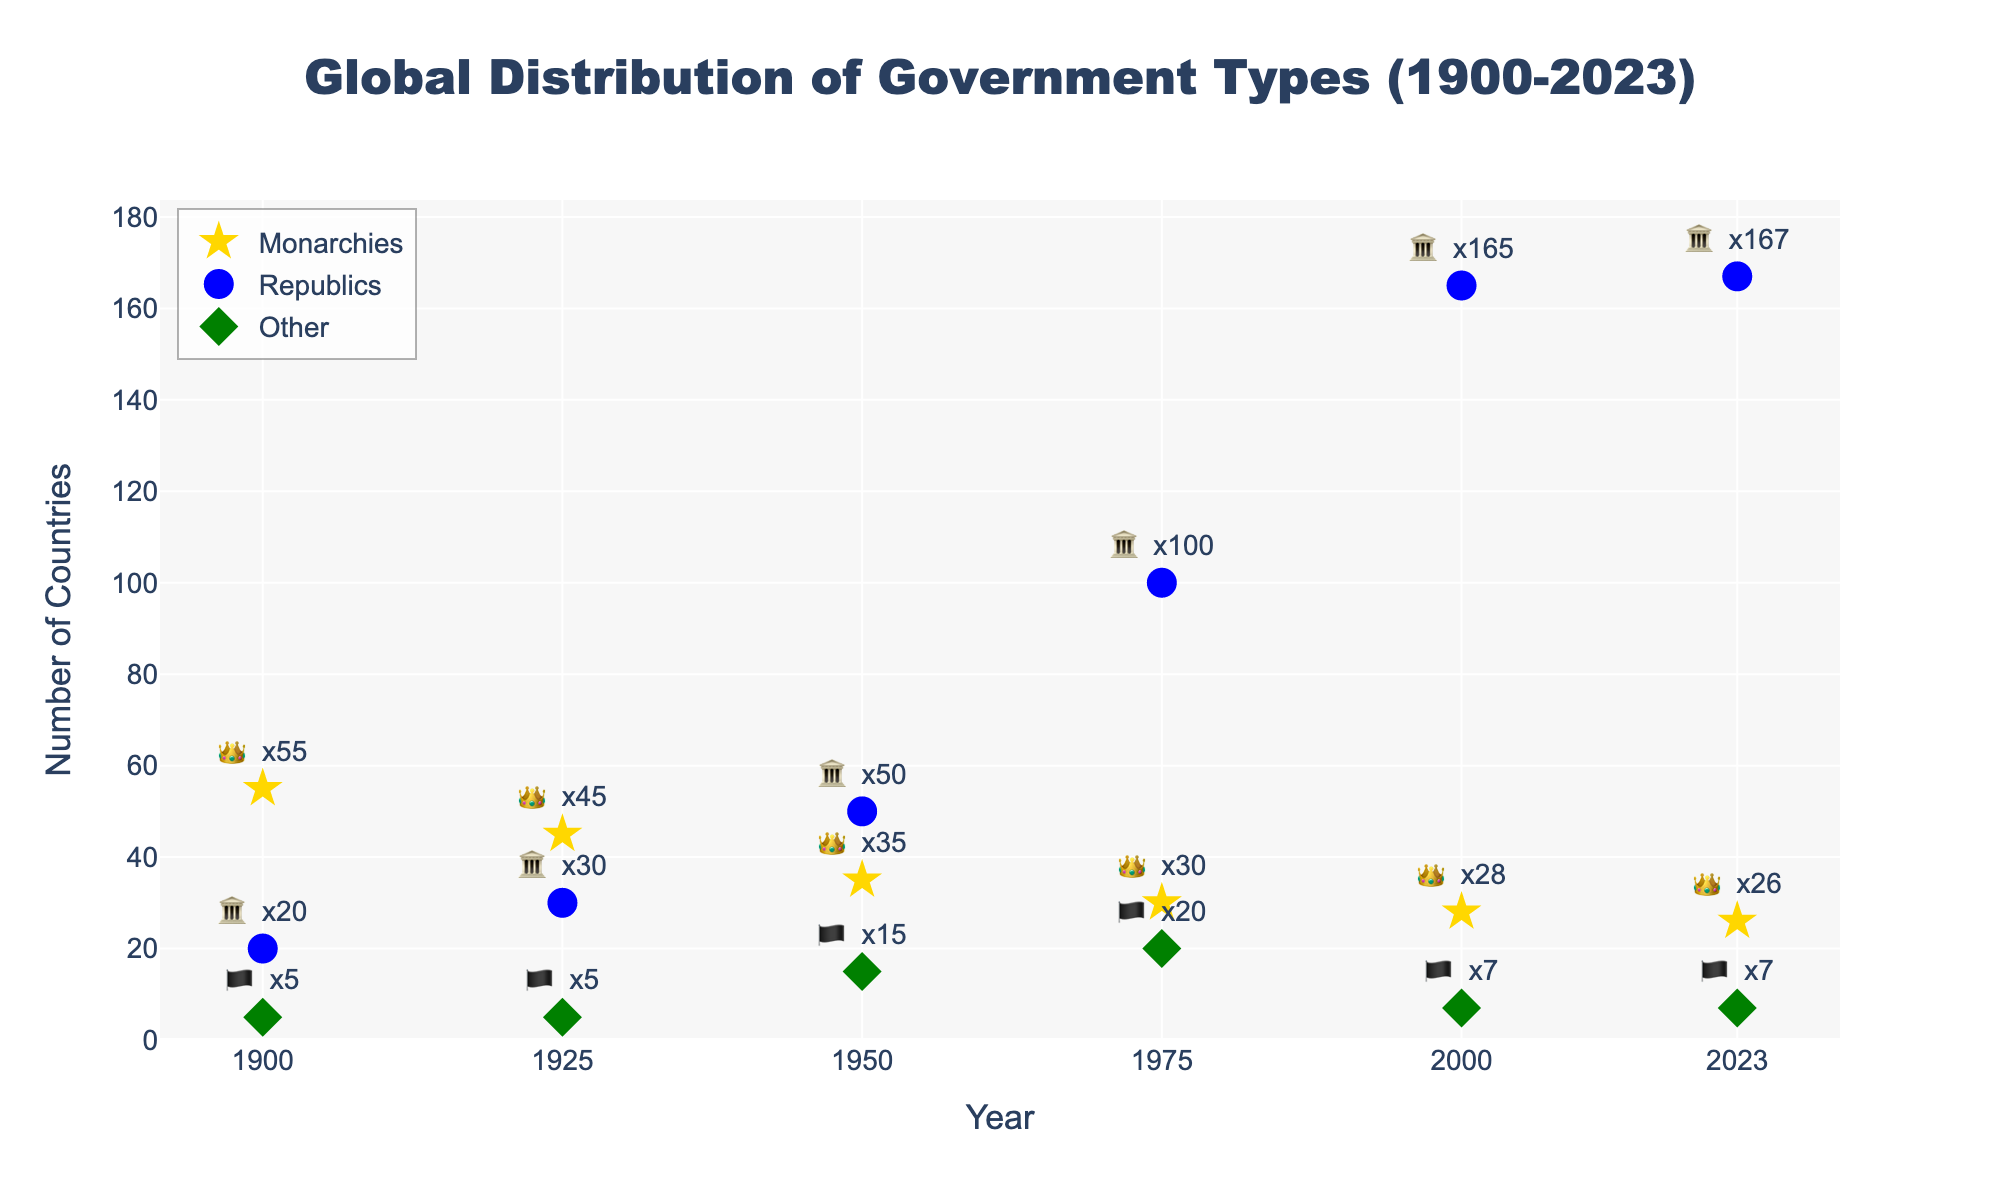what is the title of the figure? The title is directly visible at the top of the figure, often in a larger and bold font. It summarizes the subject of the plot in a few words.
Answer: Global Distribution of Government Types (1900-2023) How many monarchies were there in 1900? The number of monarchies in each year is marked by a gold star and labeled with a text indicating the count. For the year 1900, the label shows the count.
Answer: 55 Between which years did republics see the highest increase in number? To determine the period with the highest increase, we compare the number of republics between consecutive years and identify the largest difference. The largest jump occurs between 1975 (100) and 2000 (165).
Answer: 1975 to 2000 Which government type has decreased in number over time? By observing the trend lines and markers for each government type, the figure shows that monarchies (gold star symbols) have consistently decreased from 1900 to 2023.
Answer: Monarchies What is the difference in the number of republics between 2000 and 2023? Subtract the number of republics in 2000 from the number in 2023. The figure labels show 165 republics in 2000 and 167 in 2023, so the difference is 167 - 165.
Answer: 2 In which year did the number of 'Other' forms of government peak? The 'Other' forms of government are denoted by green diamond symbols. By looking at the highest point of the green diamond markers, the peak occurs in 1975.
Answer: 1975 How many countries had monarchies, republics, or other forms of government in 1950? Add the counts of monarchies, republics, and other forms of government in 1950. From the figure, these are 35 (monarchies) + 50 (republics) + 15 (other). The total is 35+50+15.
Answer: 100 Which year showed the lowest number of monarchies? The figure indicates the count of monarchies by year through gold markers and text labels. The lowest number on the plot happens in 2023.
Answer: 2023 How did the number of 'Other' forms change between 1925 and 1950? To determine the change, subtract the count in 1925 from that in 1950. The number stays the same at 5 in 1925 and increases to 15 in 1950, so the difference is 15 - 5.
Answer: Increased by 10 What was the total number of countries considered in 2023? Add up all forms of government in 2023: monarchies (26), republics (167), and other (7). The total sum is 26 + 167 + 7.
Answer: 200 